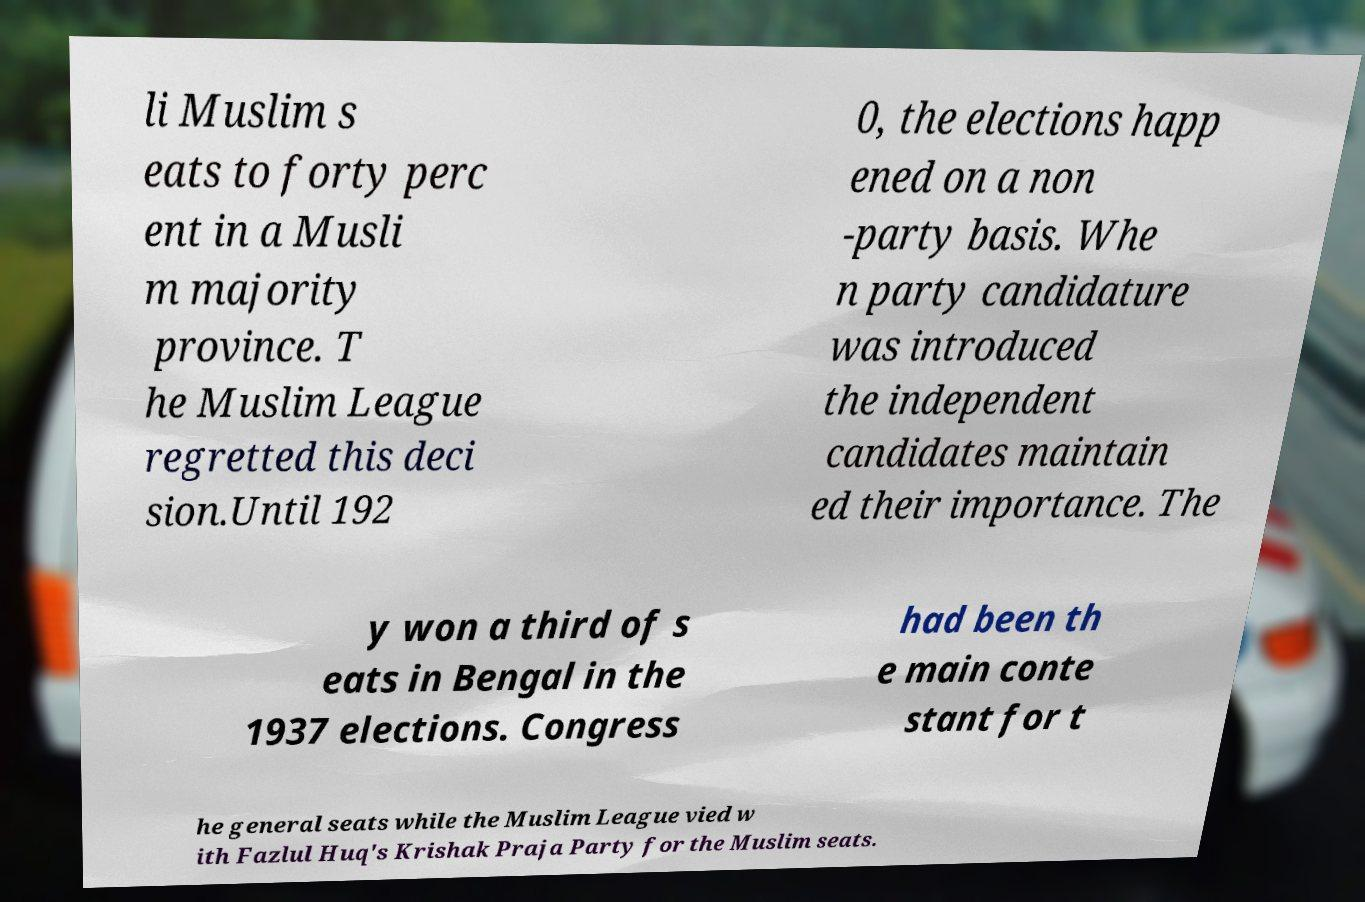I need the written content from this picture converted into text. Can you do that? li Muslim s eats to forty perc ent in a Musli m majority province. T he Muslim League regretted this deci sion.Until 192 0, the elections happ ened on a non -party basis. Whe n party candidature was introduced the independent candidates maintain ed their importance. The y won a third of s eats in Bengal in the 1937 elections. Congress had been th e main conte stant for t he general seats while the Muslim League vied w ith Fazlul Huq's Krishak Praja Party for the Muslim seats. 